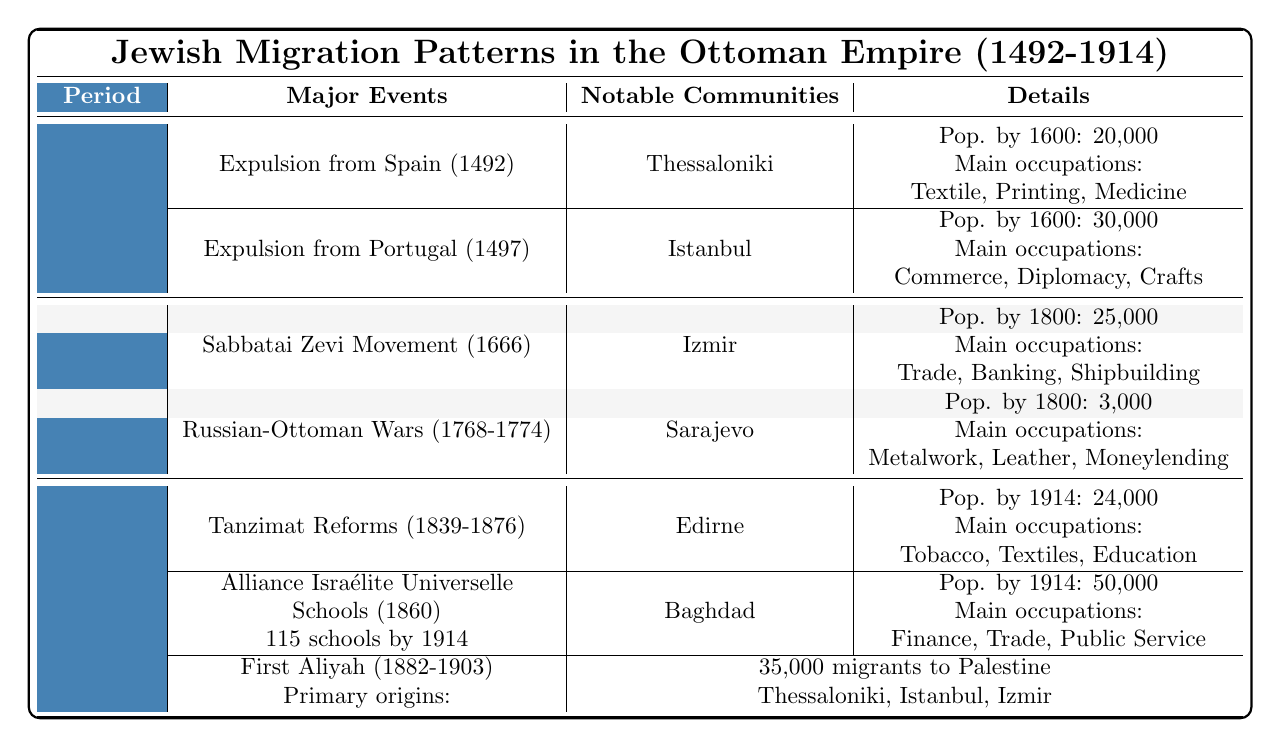What major event occurred in 1492 that affected Jewish migration? The table indicates that the expulsion from Spain in 1492 led to a significant movement of Jewish populations, with an estimated 100,000 migrants.
Answer: Expulsion from Spain How many estimated migrants came from Portugal in 1497? According to the table, 50,000 estimated migrants left Portugal in 1497.
Answer: 50,000 What city had a Jewish population of 30,000 by 1600? The table specifies that Istanbul had a Jewish population of 30,000 by the year 1600.
Answer: Istanbul Which community's main occupations included textile trade and printing? The table identifies Thessaloniki as a community where the main occupations included textile trade and printing, with a population of 20,000 by 1600.
Answer: Thessaloniki How many Jews migrated to Edirne from the Tanzimat Reforms? The table lists that the Tanzimat Reforms resulted in 50,000 internal migrants, including Edirne.
Answer: 50,000 Which city in the 1601-1800 period had a population of 3,000? The table notes that Sarajevo had a Jewish population of 3,000 by 1800.
Answer: Sarajevo What was the estimated number of followers of the Sabbatai Zevi Movement in 1666? The table states that the Sabbatai Zevi Movement in 1666 had an estimated 40,000 followers.
Answer: 40,000 Did the First Aliyah primarily consist of migrants from Edirne? The table indicates that the First Aliyah primarily originated from Thessaloniki, Istanbul, and Izmir, but does not mention Edirne as a primary origin.
Answer: No How many schools were established by the Alliance Israélite Universelle by 1914? The table reveals that there were 115 schools established by the Alliance Israélite Universelle by 1914.
Answer: 115 schools Which community had the largest Jewish population recorded by 1914? According to the table, Baghdad had the largest recorded Jewish population by 1914, with 50,000 residents.
Answer: Baghdad What was the total estimated number of migrants to Palestine during the First Aliyah? The table indicates that 35,000 migrants went to Palestine during the First Aliyah from 1882 to 1903.
Answer: 35,000 Calculate the total estimated migrants from Spain and Portugal events combined. The table shows 100,000 migrants from Spain and 50,000 from Portugal. Adding these gives 100,000 + 50,000 = 150,000 total estimated migrants.
Answer: 150,000 How did the population of Edirne in 1914 compare to that of Thessaloniki in 1600? Edirne had a population of 24,000 by 1914, while Thessaloniki had a population of 20,000 by 1600. Thus, Edirne's population was higher.
Answer: Edirne's population was higher Was there any internal migration reported as a result of the Sabbatai Zevi Movement? Based on the table, the Sabbatai Zevi Movement resulted in internal migration primarily to Izmir and surrounding areas.
Answer: Yes What are the main occupations of the Jewish community in Baghdad? The table lists finance, import-export, and public service as the main occupations of the Jewish community in Baghdad by 1914.
Answer: Finance, import-export, public service 